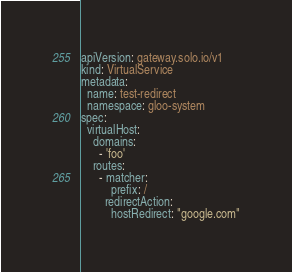Convert code to text. <code><loc_0><loc_0><loc_500><loc_500><_YAML_>apiVersion: gateway.solo.io/v1
kind: VirtualService
metadata:
  name: test-redirect
  namespace: gloo-system
spec:
  virtualHost:
    domains:
      - 'foo'
    routes:
      - matcher:
          prefix: /
        redirectAction:
          hostRedirect: "google.com"</code> 